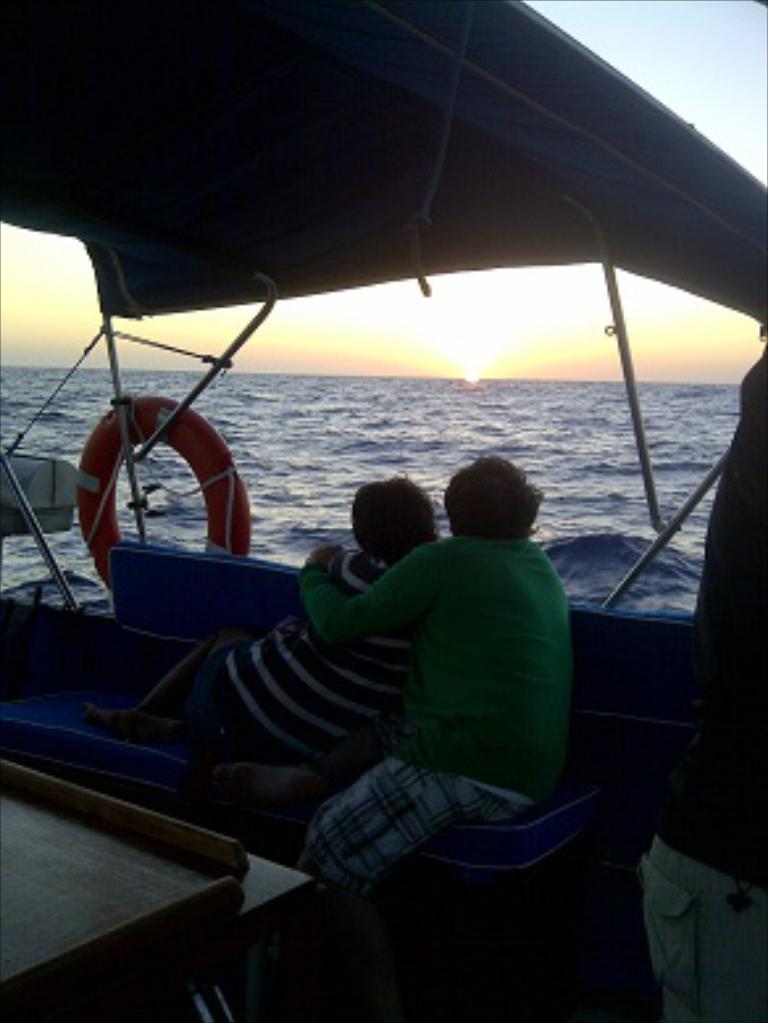Can you describe this image briefly? In the image there are persons sitting on a boat in the ocean, in the background the sun is setting down in the sky. 